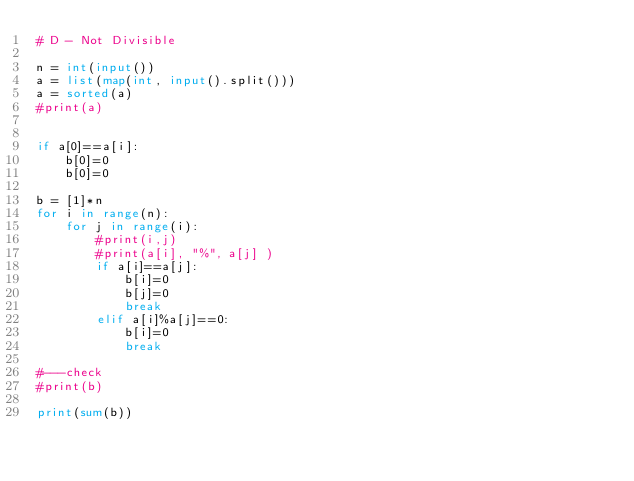Convert code to text. <code><loc_0><loc_0><loc_500><loc_500><_Python_># D - Not Divisible

n = int(input())
a = list(map(int, input().split()))
a = sorted(a)
#print(a)


if a[0]==a[i]:
    b[0]=0
    b[0]=0

b = [1]*n
for i in range(n):
    for j in range(i):
        #print(i,j)
        #print(a[i], "%", a[j] )
        if a[i]==a[j]:
            b[i]=0
            b[j]=0
            break
        elif a[i]%a[j]==0:
            b[i]=0
            break

#---check
#print(b)

print(sum(b))
        
</code> 